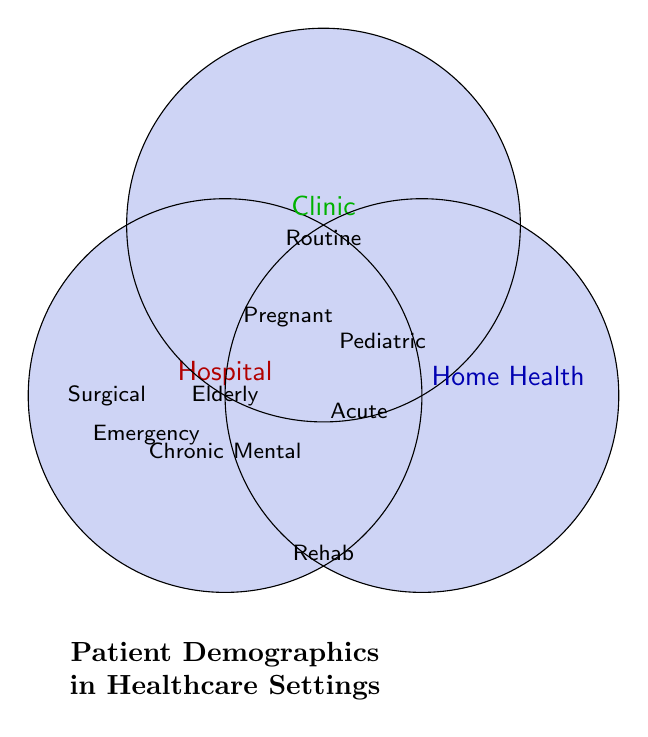What patient demographics are unique to hospitals? The figure shows several categories of patients. In the hospital circle, there are groups only found in this setting, like Surgical and Emergency cases.
Answer: Surgical, Emergency Which patient categories can be found in all three settings? By identifying where the three circles overlap in the Venn Diagram, the shared categories are in the central area. These are Elderly patients, Chronic disease patients, and Mental health patients.
Answer: Elderly, Chronic disease, Mental health Which patient types are provided for Home Health but not for Clinics? By comparing the Home Health and Clinic circles, Rehabilitation patients are the group that falls in Home Health alone.
Answer: Rehabilitation How many different patient categories does a Clinic cover? The Clinic circle includes Pediatric patients, Acute care patients, Pregnant women, Routine check-ups, Elderly patients, Chronic disease patients, and Mental health patients, totaling seven categories.
Answer: 7 What patient demographics are unique to Clinics only? The Clinic circle has Routine check-ups that do not overlap with Hospital or Home Health.
Answer: Routine check-ups Where would you find Pediatric patients? The Pediatric category is shared between the Hospital and Clinic circles and is not part of Home Health.
Answer: Hospital, Clinic 